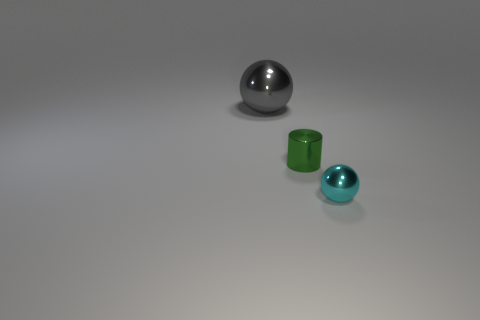Subtract all red cylinders. Subtract all cyan spheres. How many cylinders are left? 1 Add 2 large things. How many objects exist? 5 Subtract all cylinders. How many objects are left? 2 Add 1 tiny cyan shiny spheres. How many tiny cyan shiny spheres are left? 2 Add 3 green metal cylinders. How many green metal cylinders exist? 4 Subtract 0 brown spheres. How many objects are left? 3 Subtract all small shiny cylinders. Subtract all green cylinders. How many objects are left? 1 